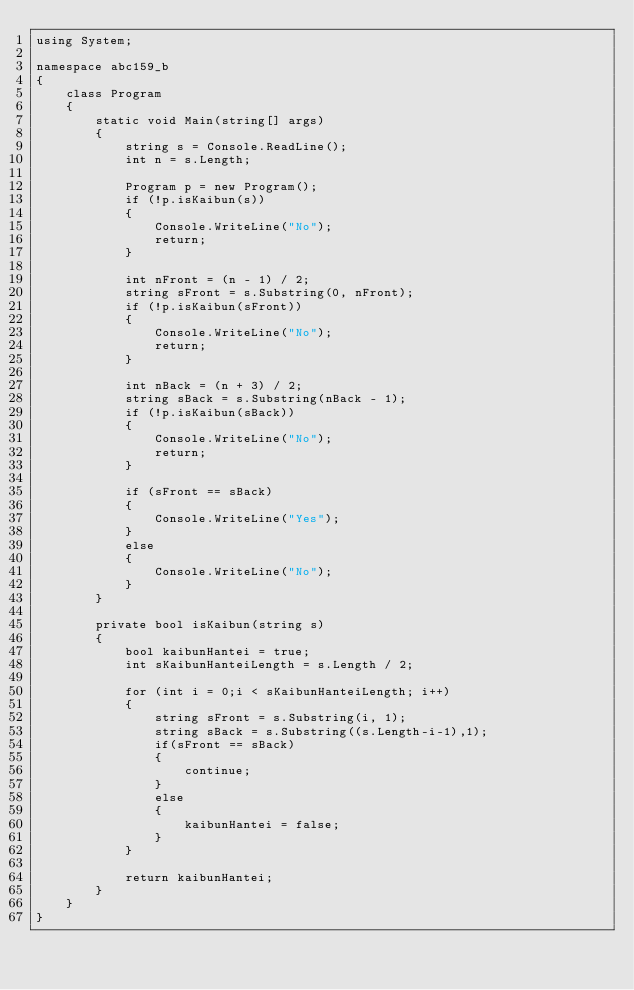Convert code to text. <code><loc_0><loc_0><loc_500><loc_500><_C#_>using System;

namespace abc159_b
{
    class Program
    {
        static void Main(string[] args)
        {
            string s = Console.ReadLine();
            int n = s.Length;

            Program p = new Program();
            if (!p.isKaibun(s))
            {
                Console.WriteLine("No");
                return;
            }

            int nFront = (n - 1) / 2;
            string sFront = s.Substring(0, nFront);
            if (!p.isKaibun(sFront))
            {
                Console.WriteLine("No");
                return;
            }

            int nBack = (n + 3) / 2;
            string sBack = s.Substring(nBack - 1);
            if (!p.isKaibun(sBack))
            {
                Console.WriteLine("No");
                return;
            }

            if (sFront == sBack)
            {
                Console.WriteLine("Yes");
            }
            else
            {
                Console.WriteLine("No");
            }
        }

        private bool isKaibun(string s)
        {
            bool kaibunHantei = true;
            int sKaibunHanteiLength = s.Length / 2;

            for (int i = 0;i < sKaibunHanteiLength; i++)
            {
                string sFront = s.Substring(i, 1);
                string sBack = s.Substring((s.Length-i-1),1);
                if(sFront == sBack)
                {
                    continue;
                }
                else
                {
                    kaibunHantei = false;
                }
            }

            return kaibunHantei;
        }
    }
}
</code> 